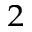<formula> <loc_0><loc_0><loc_500><loc_500>_ { 2 }</formula> 